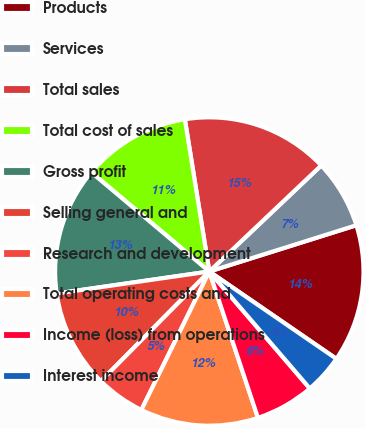<chart> <loc_0><loc_0><loc_500><loc_500><pie_chart><fcel>Products<fcel>Services<fcel>Total sales<fcel>Total cost of sales<fcel>Gross profit<fcel>Selling general and<fcel>Research and development<fcel>Total operating costs and<fcel>Income (loss) from operations<fcel>Interest income<nl><fcel>14.43%<fcel>7.22%<fcel>15.46%<fcel>11.34%<fcel>13.4%<fcel>10.31%<fcel>5.15%<fcel>12.37%<fcel>6.19%<fcel>4.12%<nl></chart> 